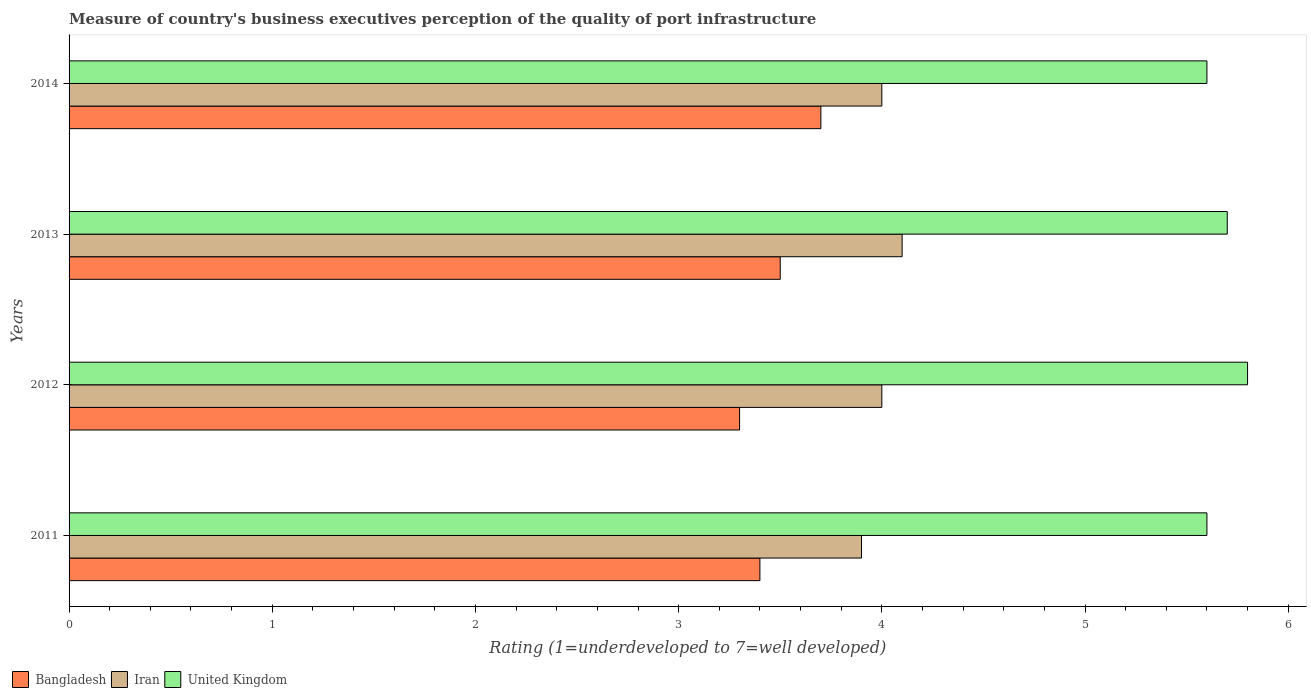How many different coloured bars are there?
Make the answer very short. 3. Are the number of bars per tick equal to the number of legend labels?
Offer a very short reply. Yes. Are the number of bars on each tick of the Y-axis equal?
Give a very brief answer. Yes. How many bars are there on the 2nd tick from the top?
Keep it short and to the point. 3. How many bars are there on the 1st tick from the bottom?
Your answer should be compact. 3. What is the label of the 3rd group of bars from the top?
Make the answer very short. 2012. In how many cases, is the number of bars for a given year not equal to the number of legend labels?
Offer a terse response. 0. What is the ratings of the quality of port infrastructure in Bangladesh in 2012?
Ensure brevity in your answer.  3.3. Across all years, what is the maximum ratings of the quality of port infrastructure in Bangladesh?
Make the answer very short. 3.7. What is the total ratings of the quality of port infrastructure in United Kingdom in the graph?
Your answer should be very brief. 22.7. What is the difference between the ratings of the quality of port infrastructure in Iran in 2011 and that in 2013?
Keep it short and to the point. -0.2. What is the difference between the ratings of the quality of port infrastructure in Iran in 2014 and the ratings of the quality of port infrastructure in United Kingdom in 2012?
Keep it short and to the point. -1.8. What is the average ratings of the quality of port infrastructure in Bangladesh per year?
Your answer should be compact. 3.47. What is the ratio of the ratings of the quality of port infrastructure in United Kingdom in 2012 to that in 2014?
Provide a short and direct response. 1.04. Is the ratings of the quality of port infrastructure in Bangladesh in 2012 less than that in 2014?
Keep it short and to the point. Yes. Is the difference between the ratings of the quality of port infrastructure in Iran in 2011 and 2013 greater than the difference between the ratings of the quality of port infrastructure in Bangladesh in 2011 and 2013?
Ensure brevity in your answer.  No. What is the difference between the highest and the second highest ratings of the quality of port infrastructure in Iran?
Your response must be concise. 0.1. What is the difference between the highest and the lowest ratings of the quality of port infrastructure in Iran?
Your response must be concise. 0.2. What does the 1st bar from the top in 2014 represents?
Your response must be concise. United Kingdom. What does the 1st bar from the bottom in 2014 represents?
Provide a short and direct response. Bangladesh. How many bars are there?
Provide a succinct answer. 12. What is the difference between two consecutive major ticks on the X-axis?
Make the answer very short. 1. Where does the legend appear in the graph?
Make the answer very short. Bottom left. What is the title of the graph?
Your response must be concise. Measure of country's business executives perception of the quality of port infrastructure. What is the label or title of the X-axis?
Your answer should be compact. Rating (1=underdeveloped to 7=well developed). What is the Rating (1=underdeveloped to 7=well developed) in Bangladesh in 2011?
Provide a succinct answer. 3.4. What is the Rating (1=underdeveloped to 7=well developed) in United Kingdom in 2011?
Your answer should be very brief. 5.6. What is the Rating (1=underdeveloped to 7=well developed) of Bangladesh in 2012?
Provide a succinct answer. 3.3. What is the Rating (1=underdeveloped to 7=well developed) of Iran in 2013?
Offer a very short reply. 4.1. What is the Rating (1=underdeveloped to 7=well developed) of United Kingdom in 2013?
Provide a succinct answer. 5.7. What is the Rating (1=underdeveloped to 7=well developed) in Iran in 2014?
Your response must be concise. 4. Across all years, what is the minimum Rating (1=underdeveloped to 7=well developed) of Iran?
Offer a terse response. 3.9. Across all years, what is the minimum Rating (1=underdeveloped to 7=well developed) of United Kingdom?
Provide a succinct answer. 5.6. What is the total Rating (1=underdeveloped to 7=well developed) of United Kingdom in the graph?
Offer a very short reply. 22.7. What is the difference between the Rating (1=underdeveloped to 7=well developed) of Bangladesh in 2011 and that in 2013?
Your response must be concise. -0.1. What is the difference between the Rating (1=underdeveloped to 7=well developed) of Iran in 2011 and that in 2014?
Offer a terse response. -0.1. What is the difference between the Rating (1=underdeveloped to 7=well developed) in United Kingdom in 2011 and that in 2014?
Offer a terse response. 0. What is the difference between the Rating (1=underdeveloped to 7=well developed) of Bangladesh in 2012 and that in 2013?
Keep it short and to the point. -0.2. What is the difference between the Rating (1=underdeveloped to 7=well developed) in Bangladesh in 2012 and that in 2014?
Give a very brief answer. -0.4. What is the difference between the Rating (1=underdeveloped to 7=well developed) in Iran in 2012 and that in 2014?
Provide a short and direct response. 0. What is the difference between the Rating (1=underdeveloped to 7=well developed) of Bangladesh in 2013 and that in 2014?
Give a very brief answer. -0.2. What is the difference between the Rating (1=underdeveloped to 7=well developed) of Iran in 2013 and that in 2014?
Ensure brevity in your answer.  0.1. What is the difference between the Rating (1=underdeveloped to 7=well developed) in United Kingdom in 2013 and that in 2014?
Ensure brevity in your answer.  0.1. What is the difference between the Rating (1=underdeveloped to 7=well developed) of Bangladesh in 2011 and the Rating (1=underdeveloped to 7=well developed) of Iran in 2012?
Provide a succinct answer. -0.6. What is the difference between the Rating (1=underdeveloped to 7=well developed) in Bangladesh in 2011 and the Rating (1=underdeveloped to 7=well developed) in Iran in 2013?
Your response must be concise. -0.7. What is the difference between the Rating (1=underdeveloped to 7=well developed) of Bangladesh in 2011 and the Rating (1=underdeveloped to 7=well developed) of United Kingdom in 2013?
Offer a very short reply. -2.3. What is the difference between the Rating (1=underdeveloped to 7=well developed) of Bangladesh in 2011 and the Rating (1=underdeveloped to 7=well developed) of Iran in 2014?
Offer a very short reply. -0.6. What is the difference between the Rating (1=underdeveloped to 7=well developed) in Bangladesh in 2012 and the Rating (1=underdeveloped to 7=well developed) in United Kingdom in 2013?
Ensure brevity in your answer.  -2.4. What is the difference between the Rating (1=underdeveloped to 7=well developed) in Iran in 2012 and the Rating (1=underdeveloped to 7=well developed) in United Kingdom in 2013?
Keep it short and to the point. -1.7. What is the difference between the Rating (1=underdeveloped to 7=well developed) of Bangladesh in 2012 and the Rating (1=underdeveloped to 7=well developed) of Iran in 2014?
Offer a terse response. -0.7. What is the average Rating (1=underdeveloped to 7=well developed) in Bangladesh per year?
Your answer should be very brief. 3.48. What is the average Rating (1=underdeveloped to 7=well developed) of Iran per year?
Offer a terse response. 4. What is the average Rating (1=underdeveloped to 7=well developed) of United Kingdom per year?
Make the answer very short. 5.67. In the year 2011, what is the difference between the Rating (1=underdeveloped to 7=well developed) of Bangladesh and Rating (1=underdeveloped to 7=well developed) of United Kingdom?
Provide a succinct answer. -2.2. In the year 2012, what is the difference between the Rating (1=underdeveloped to 7=well developed) of Bangladesh and Rating (1=underdeveloped to 7=well developed) of United Kingdom?
Give a very brief answer. -2.5. In the year 2012, what is the difference between the Rating (1=underdeveloped to 7=well developed) in Iran and Rating (1=underdeveloped to 7=well developed) in United Kingdom?
Ensure brevity in your answer.  -1.8. In the year 2013, what is the difference between the Rating (1=underdeveloped to 7=well developed) of Bangladesh and Rating (1=underdeveloped to 7=well developed) of United Kingdom?
Offer a very short reply. -2.2. In the year 2013, what is the difference between the Rating (1=underdeveloped to 7=well developed) in Iran and Rating (1=underdeveloped to 7=well developed) in United Kingdom?
Provide a short and direct response. -1.6. In the year 2014, what is the difference between the Rating (1=underdeveloped to 7=well developed) in Bangladesh and Rating (1=underdeveloped to 7=well developed) in United Kingdom?
Offer a very short reply. -1.9. In the year 2014, what is the difference between the Rating (1=underdeveloped to 7=well developed) in Iran and Rating (1=underdeveloped to 7=well developed) in United Kingdom?
Keep it short and to the point. -1.6. What is the ratio of the Rating (1=underdeveloped to 7=well developed) of Bangladesh in 2011 to that in 2012?
Your answer should be compact. 1.03. What is the ratio of the Rating (1=underdeveloped to 7=well developed) of Iran in 2011 to that in 2012?
Give a very brief answer. 0.97. What is the ratio of the Rating (1=underdeveloped to 7=well developed) of United Kingdom in 2011 to that in 2012?
Provide a succinct answer. 0.97. What is the ratio of the Rating (1=underdeveloped to 7=well developed) in Bangladesh in 2011 to that in 2013?
Your answer should be compact. 0.97. What is the ratio of the Rating (1=underdeveloped to 7=well developed) of Iran in 2011 to that in 2013?
Provide a succinct answer. 0.95. What is the ratio of the Rating (1=underdeveloped to 7=well developed) in United Kingdom in 2011 to that in 2013?
Keep it short and to the point. 0.98. What is the ratio of the Rating (1=underdeveloped to 7=well developed) of Bangladesh in 2011 to that in 2014?
Make the answer very short. 0.92. What is the ratio of the Rating (1=underdeveloped to 7=well developed) of United Kingdom in 2011 to that in 2014?
Offer a very short reply. 1. What is the ratio of the Rating (1=underdeveloped to 7=well developed) in Bangladesh in 2012 to that in 2013?
Offer a very short reply. 0.94. What is the ratio of the Rating (1=underdeveloped to 7=well developed) in Iran in 2012 to that in 2013?
Your response must be concise. 0.98. What is the ratio of the Rating (1=underdeveloped to 7=well developed) of United Kingdom in 2012 to that in 2013?
Your response must be concise. 1.02. What is the ratio of the Rating (1=underdeveloped to 7=well developed) in Bangladesh in 2012 to that in 2014?
Give a very brief answer. 0.89. What is the ratio of the Rating (1=underdeveloped to 7=well developed) of Iran in 2012 to that in 2014?
Offer a very short reply. 1. What is the ratio of the Rating (1=underdeveloped to 7=well developed) in United Kingdom in 2012 to that in 2014?
Your response must be concise. 1.04. What is the ratio of the Rating (1=underdeveloped to 7=well developed) in Bangladesh in 2013 to that in 2014?
Offer a terse response. 0.95. What is the ratio of the Rating (1=underdeveloped to 7=well developed) of Iran in 2013 to that in 2014?
Offer a very short reply. 1.02. What is the ratio of the Rating (1=underdeveloped to 7=well developed) in United Kingdom in 2013 to that in 2014?
Ensure brevity in your answer.  1.02. What is the difference between the highest and the lowest Rating (1=underdeveloped to 7=well developed) in Bangladesh?
Provide a succinct answer. 0.4. What is the difference between the highest and the lowest Rating (1=underdeveloped to 7=well developed) in Iran?
Your response must be concise. 0.2. What is the difference between the highest and the lowest Rating (1=underdeveloped to 7=well developed) of United Kingdom?
Provide a short and direct response. 0.2. 